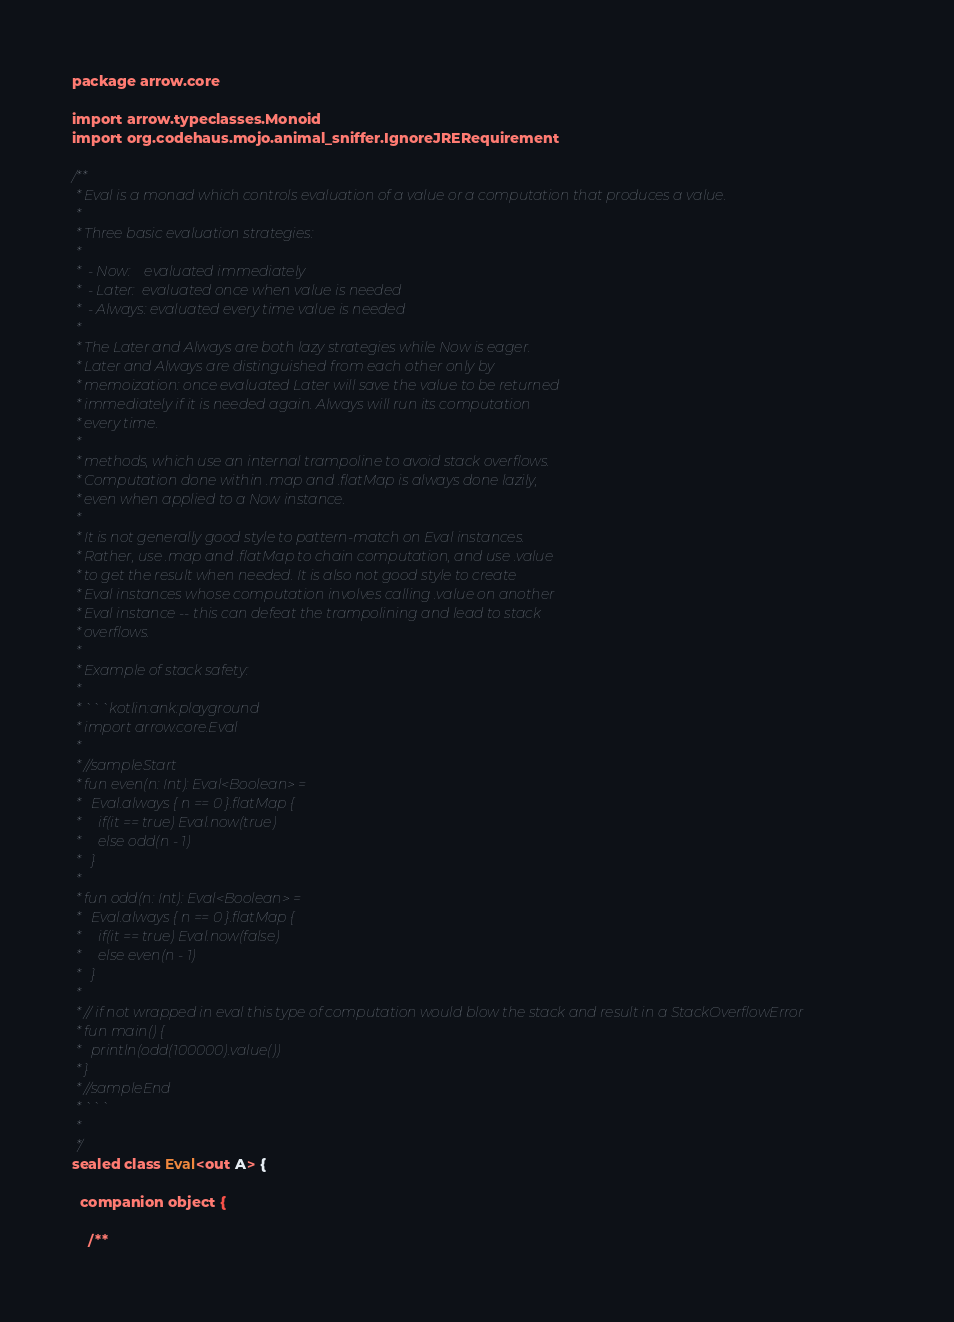Convert code to text. <code><loc_0><loc_0><loc_500><loc_500><_Kotlin_>package arrow.core

import arrow.typeclasses.Monoid
import org.codehaus.mojo.animal_sniffer.IgnoreJRERequirement

/**
 * Eval is a monad which controls evaluation of a value or a computation that produces a value.
 *
 * Three basic evaluation strategies:
 *
 *  - Now:    evaluated immediately
 *  - Later:  evaluated once when value is needed
 *  - Always: evaluated every time value is needed
 *
 * The Later and Always are both lazy strategies while Now is eager.
 * Later and Always are distinguished from each other only by
 * memoization: once evaluated Later will save the value to be returned
 * immediately if it is needed again. Always will run its computation
 * every time.
 *
 * methods, which use an internal trampoline to avoid stack overflows.
 * Computation done within .map and .flatMap is always done lazily,
 * even when applied to a Now instance.
 *
 * It is not generally good style to pattern-match on Eval instances.
 * Rather, use .map and .flatMap to chain computation, and use .value
 * to get the result when needed. It is also not good style to create
 * Eval instances whose computation involves calling .value on another
 * Eval instance -- this can defeat the trampolining and lead to stack
 * overflows.
 *
 * Example of stack safety:
 *
 * ```kotlin:ank:playground
 * import arrow.core.Eval
 *
 * //sampleStart
 * fun even(n: Int): Eval<Boolean> =
 *   Eval.always { n == 0 }.flatMap {
 *     if(it == true) Eval.now(true)
 *     else odd(n - 1)
 *   }
 *
 * fun odd(n: Int): Eval<Boolean> =
 *   Eval.always { n == 0 }.flatMap {
 *     if(it == true) Eval.now(false)
 *     else even(n - 1)
 *   }
 *
 * // if not wrapped in eval this type of computation would blow the stack and result in a StackOverflowError
 * fun main() {
 *   println(odd(100000).value())
 * }
 * //sampleEnd
 * ```
 *
 */
sealed class Eval<out A> {

  companion object {

    /**</code> 